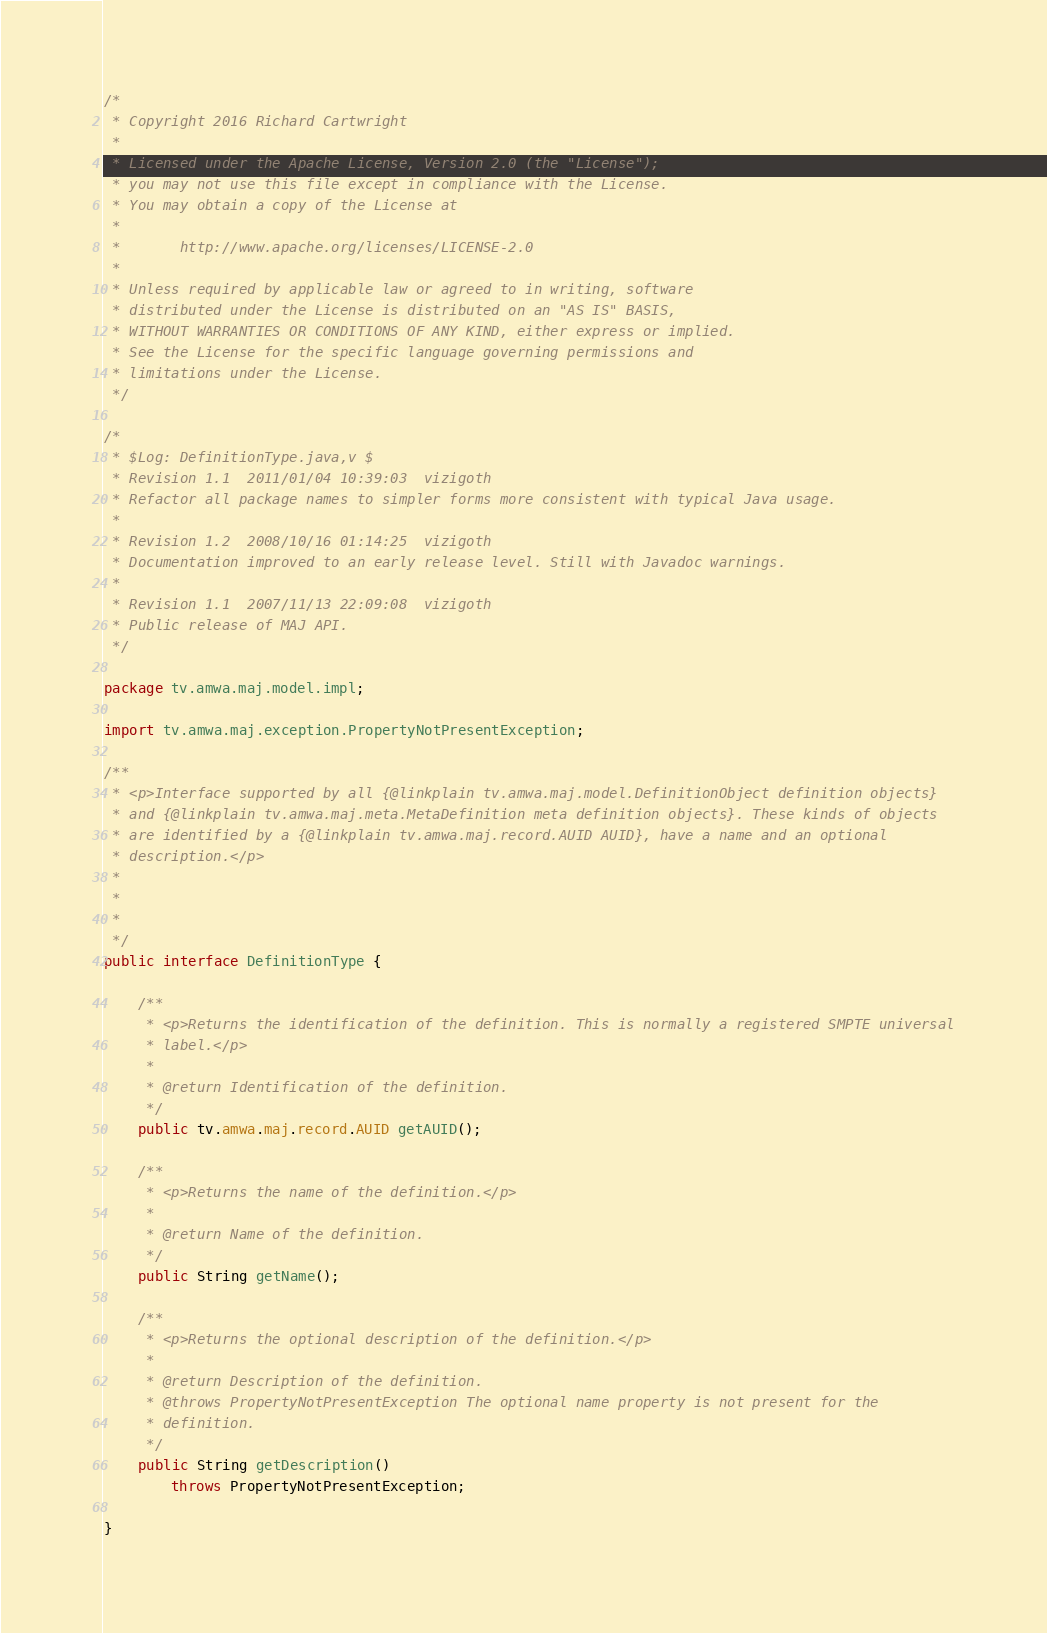Convert code to text. <code><loc_0><loc_0><loc_500><loc_500><_Java_>/*
 * Copyright 2016 Richard Cartwright
 *
 * Licensed under the Apache License, Version 2.0 (the "License");
 * you may not use this file except in compliance with the License.
 * You may obtain a copy of the License at
 *
 *       http://www.apache.org/licenses/LICENSE-2.0
 *
 * Unless required by applicable law or agreed to in writing, software
 * distributed under the License is distributed on an "AS IS" BASIS,
 * WITHOUT WARRANTIES OR CONDITIONS OF ANY KIND, either express or implied.
 * See the License for the specific language governing permissions and
 * limitations under the License.
 */

/*
 * $Log: DefinitionType.java,v $
 * Revision 1.1  2011/01/04 10:39:03  vizigoth
 * Refactor all package names to simpler forms more consistent with typical Java usage.
 *
 * Revision 1.2  2008/10/16 01:14:25  vizigoth
 * Documentation improved to an early release level. Still with Javadoc warnings.
 *
 * Revision 1.1  2007/11/13 22:09:08  vizigoth
 * Public release of MAJ API.
 */

package tv.amwa.maj.model.impl;

import tv.amwa.maj.exception.PropertyNotPresentException;

/**
 * <p>Interface supported by all {@linkplain tv.amwa.maj.model.DefinitionObject definition objects}
 * and {@linkplain tv.amwa.maj.meta.MetaDefinition meta definition objects}. These kinds of objects
 * are identified by a {@linkplain tv.amwa.maj.record.AUID AUID}, have a name and an optional
 * description.</p>
 * 
 *
 *
 */
public interface DefinitionType {

	/**
	 * <p>Returns the identification of the definition. This is normally a registered SMPTE universal
	 * label.</p>
	 * 
	 * @return Identification of the definition.
	 */
	public tv.amwa.maj.record.AUID getAUID();
	
	/**
	 * <p>Returns the name of the definition.</p>
	 * 
	 * @return Name of the definition.
	 */
	public String getName();
	
	/**
	 * <p>Returns the optional description of the definition.</p>
	 * 
	 * @return Description of the definition.
	 * @throws PropertyNotPresentException The optional name property is not present for the
	 * definition.
	 */
	public String getDescription()
		throws PropertyNotPresentException;
	
}
</code> 